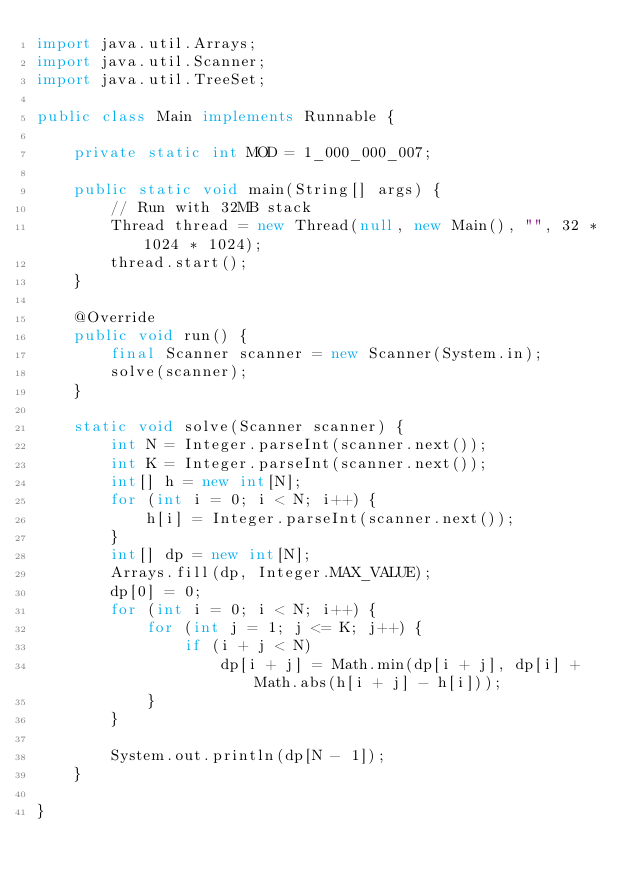Convert code to text. <code><loc_0><loc_0><loc_500><loc_500><_Java_>import java.util.Arrays;
import java.util.Scanner;
import java.util.TreeSet;

public class Main implements Runnable {

    private static int MOD = 1_000_000_007;

    public static void main(String[] args) {
        // Run with 32MB stack
        Thread thread = new Thread(null, new Main(), "", 32 * 1024 * 1024);
        thread.start();
    }

    @Override
    public void run() {
        final Scanner scanner = new Scanner(System.in);
        solve(scanner);
    }

    static void solve(Scanner scanner) {
        int N = Integer.parseInt(scanner.next());
        int K = Integer.parseInt(scanner.next());
        int[] h = new int[N];
        for (int i = 0; i < N; i++) {
            h[i] = Integer.parseInt(scanner.next());
        }
        int[] dp = new int[N];
        Arrays.fill(dp, Integer.MAX_VALUE);
        dp[0] = 0;
        for (int i = 0; i < N; i++) {
            for (int j = 1; j <= K; j++) {
                if (i + j < N)
                    dp[i + j] = Math.min(dp[i + j], dp[i] + Math.abs(h[i + j] - h[i]));
            }
        }

        System.out.println(dp[N - 1]);
    }

}

</code> 